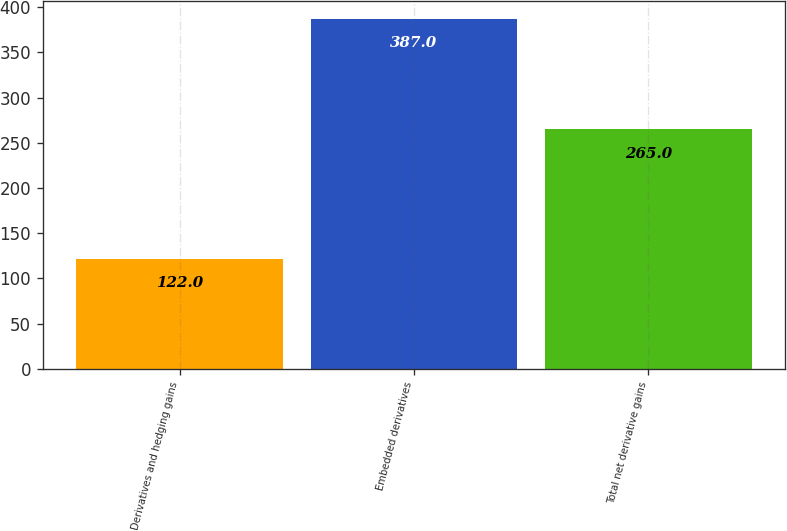Convert chart. <chart><loc_0><loc_0><loc_500><loc_500><bar_chart><fcel>Derivatives and hedging gains<fcel>Embedded derivatives<fcel>Total net derivative gains<nl><fcel>122<fcel>387<fcel>265<nl></chart> 